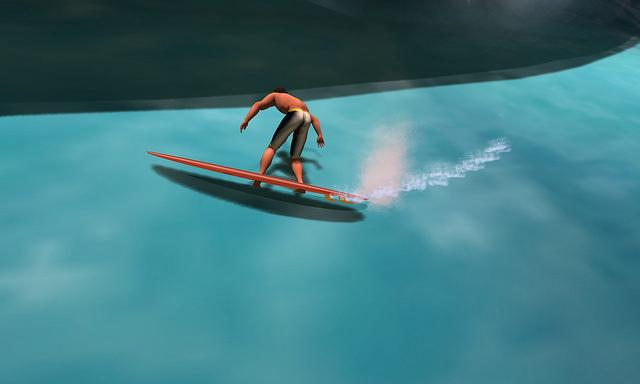How was this artwork created?

Choices:
A) photographed
B) digitally
C) painted
D) videoed digitally 